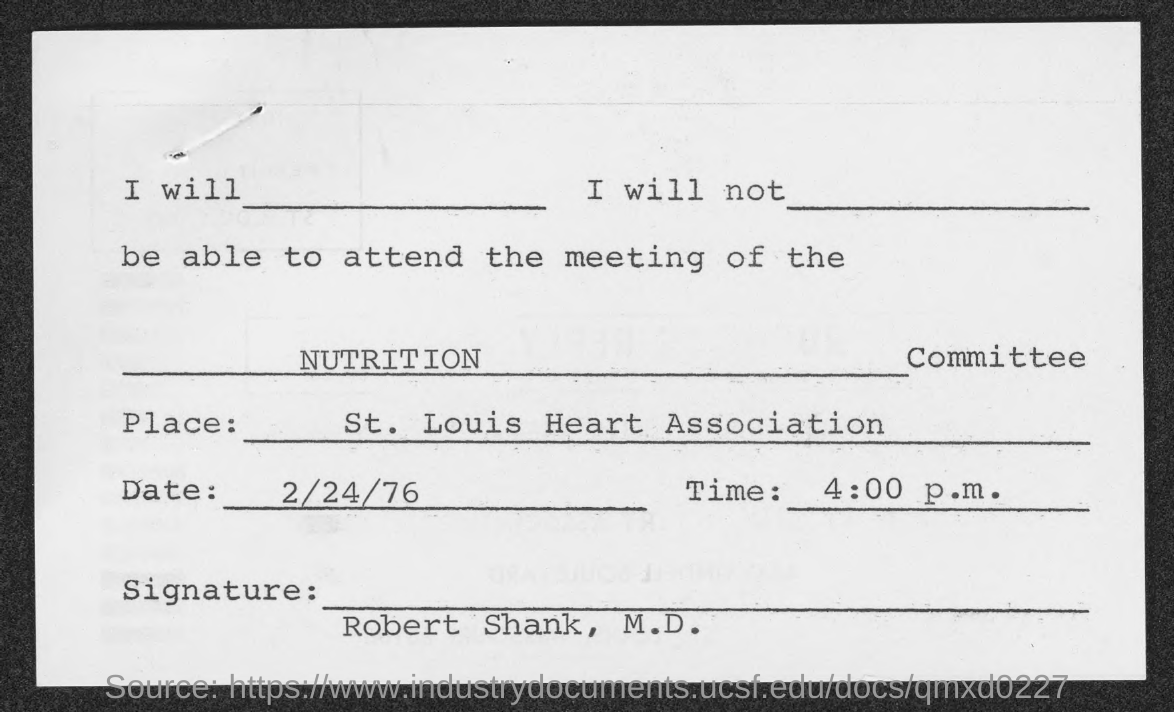Mention a couple of crucial points in this snapshot. The document has been signed by Robert Shank, M.D. The Nutrition Committee meeting is held on February 24, 1976. The Nutrition Committee meeting is scheduled for 2/24/76 at 4:00 p.m. The Nutrition Committee meeting is held at the St. Louis Heart Association. 